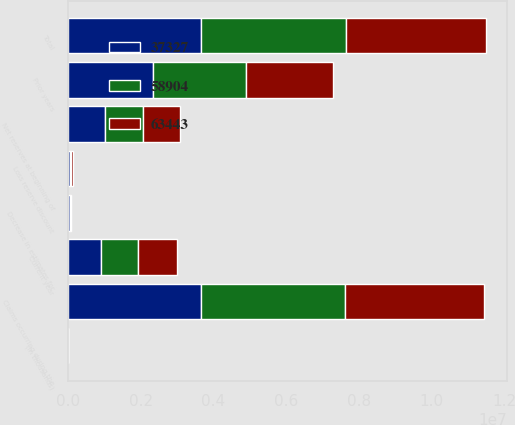Convert chart. <chart><loc_0><loc_0><loc_500><loc_500><stacked_bar_chart><ecel><fcel>(In thousands)<fcel>Net reserves at beginning of<fcel>Claims occurring during the<fcel>Decrease in estimates for<fcel>Loss reserve discount<fcel>Total<fcel>Current year<fcel>Prior years<nl><fcel>58904<fcel>2017<fcel>1.0274e+06<fcel>3.96354e+06<fcel>5165<fcel>43970<fcel>4.00235e+06<fcel>1.0274e+06<fcel>2.56255e+06<nl><fcel>63443<fcel>2016<fcel>1.0274e+06<fcel>3.82662e+06<fcel>29904<fcel>49084<fcel>3.8458e+06<fcel>1.05245e+06<fcel>2.40172e+06<nl><fcel>37327<fcel>2015<fcel>1.0274e+06<fcel>3.65356e+06<fcel>46713<fcel>49422<fcel>3.65627e+06<fcel>914637<fcel>2.34238e+06<nl></chart> 